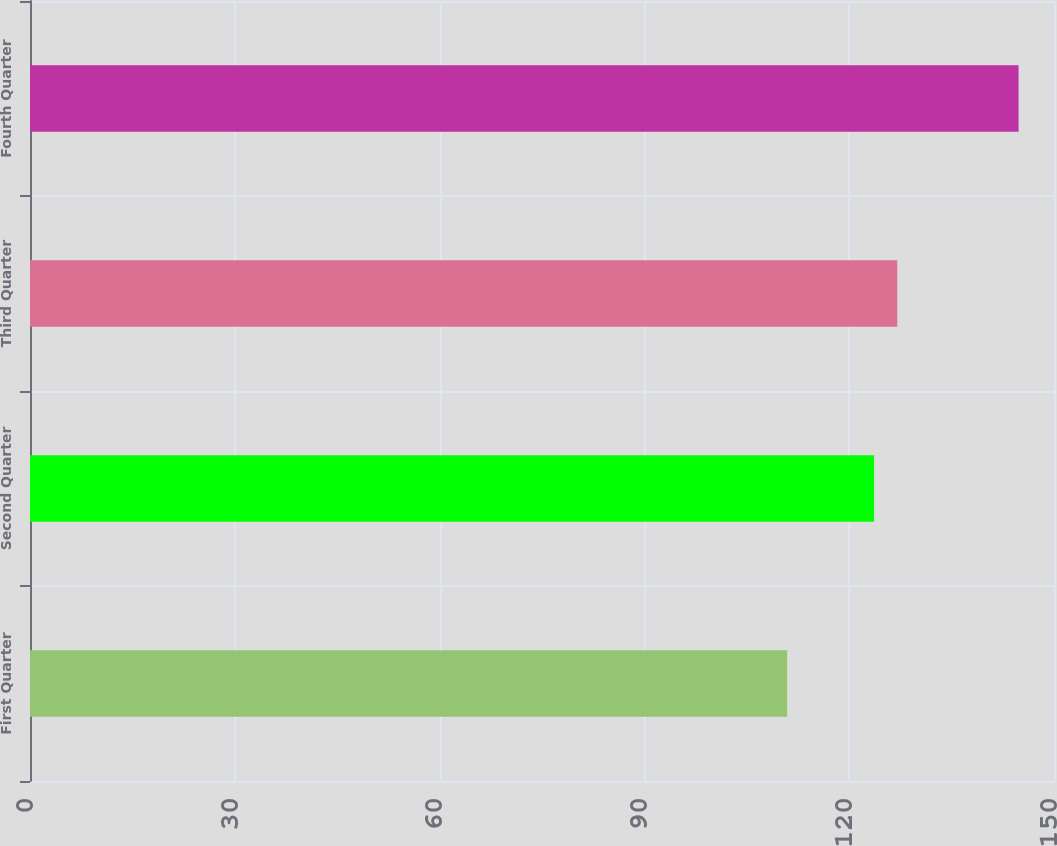<chart> <loc_0><loc_0><loc_500><loc_500><bar_chart><fcel>First Quarter<fcel>Second Quarter<fcel>Third Quarter<fcel>Fourth Quarter<nl><fcel>110.91<fcel>123.65<fcel>127.04<fcel>144.81<nl></chart> 